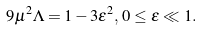<formula> <loc_0><loc_0><loc_500><loc_500>9 \mu ^ { 2 } \Lambda = 1 - 3 \epsilon ^ { 2 } , \, 0 \leq \epsilon \ll 1 .</formula> 